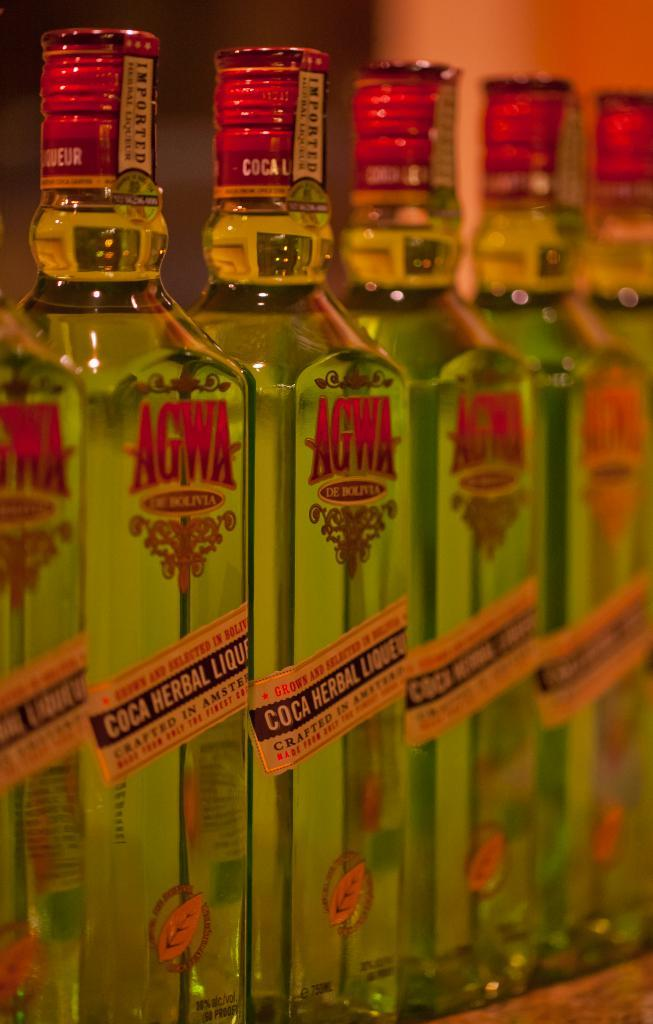<image>
Offer a succinct explanation of the picture presented. Bottles of AGWA, a Coca Herbal Liquor, are lined up next to each other. 